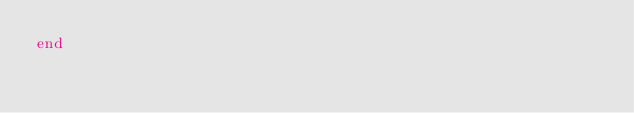Convert code to text. <code><loc_0><loc_0><loc_500><loc_500><_Ruby_>end
</code> 